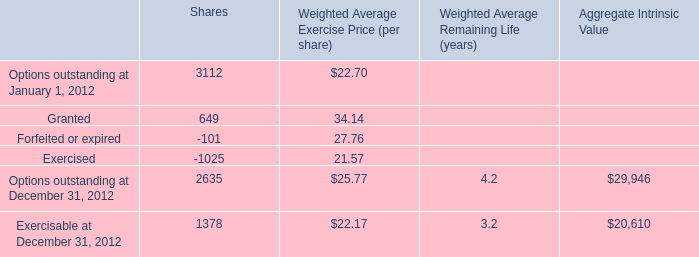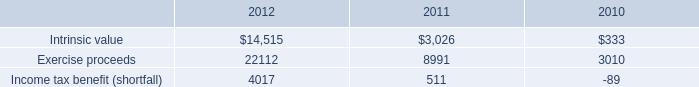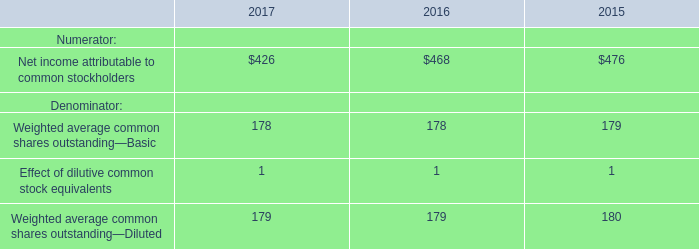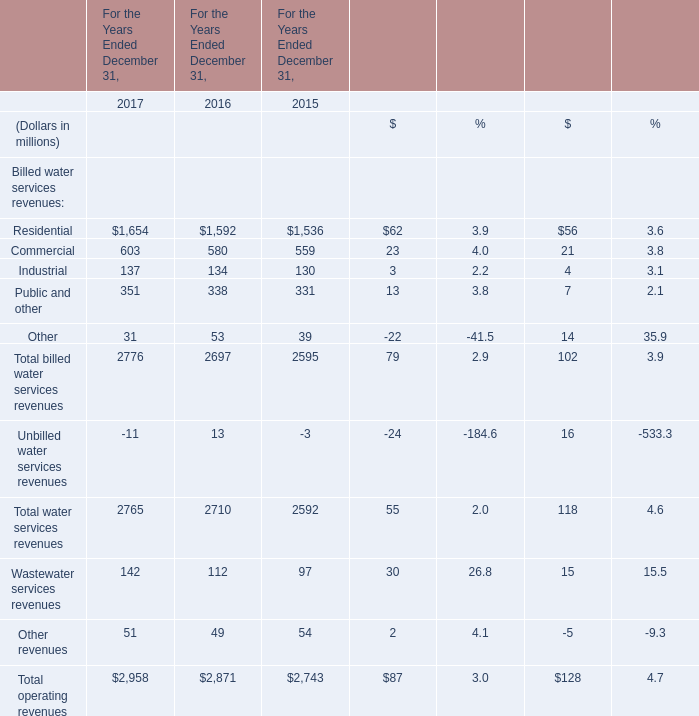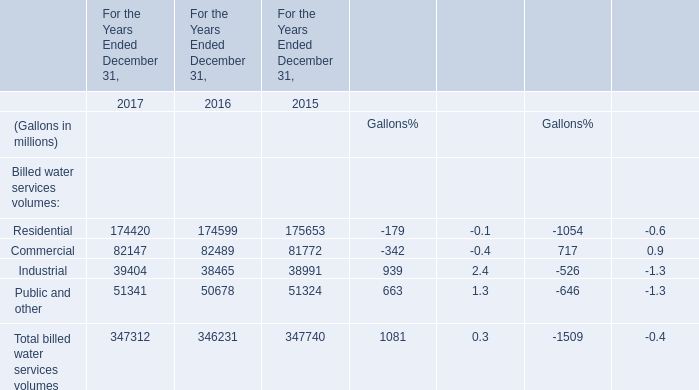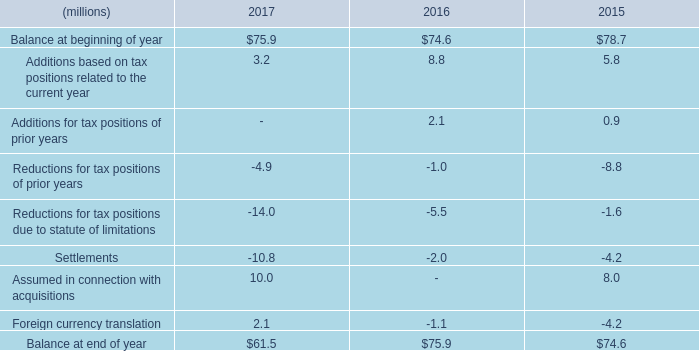What's the sum of (Gallons in millions) in 2017? (in million) 
Computations: (((174420 + 82147) + 39404) + 51341)
Answer: 347312.0. 